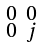<formula> <loc_0><loc_0><loc_500><loc_500>\begin{smallmatrix} 0 & 0 \\ 0 & j \end{smallmatrix}</formula> 